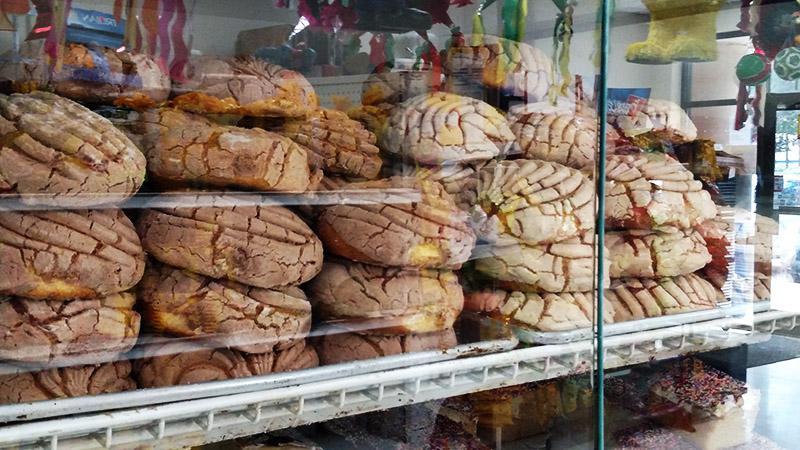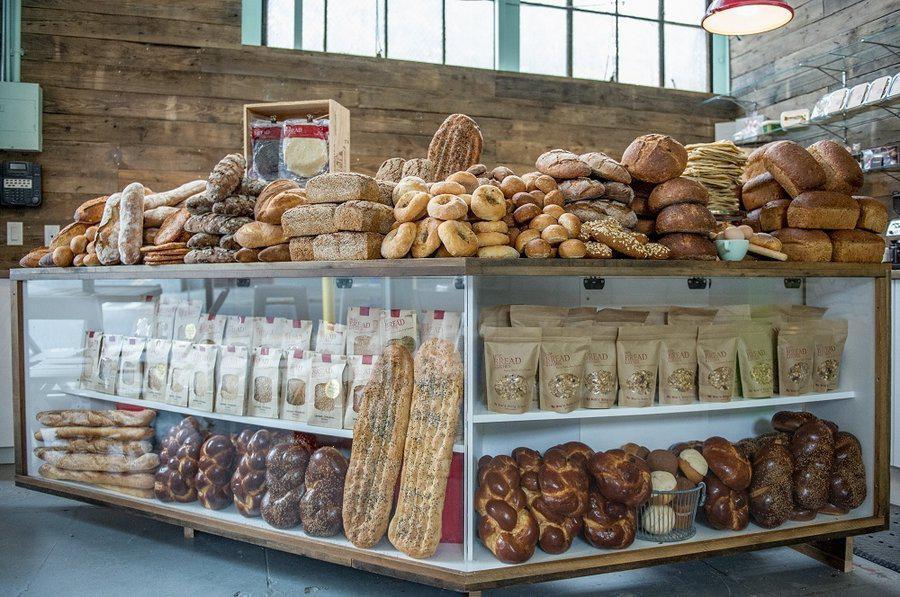The first image is the image on the left, the second image is the image on the right. Analyze the images presented: Is the assertion "In the left image, the word bakery is present." valid? Answer yes or no. No. The first image is the image on the left, the second image is the image on the right. For the images displayed, is the sentence "The right image shows at least one person in a hat standing behind a straight glass-fronted cabinet filled with baked treats." factually correct? Answer yes or no. No. 